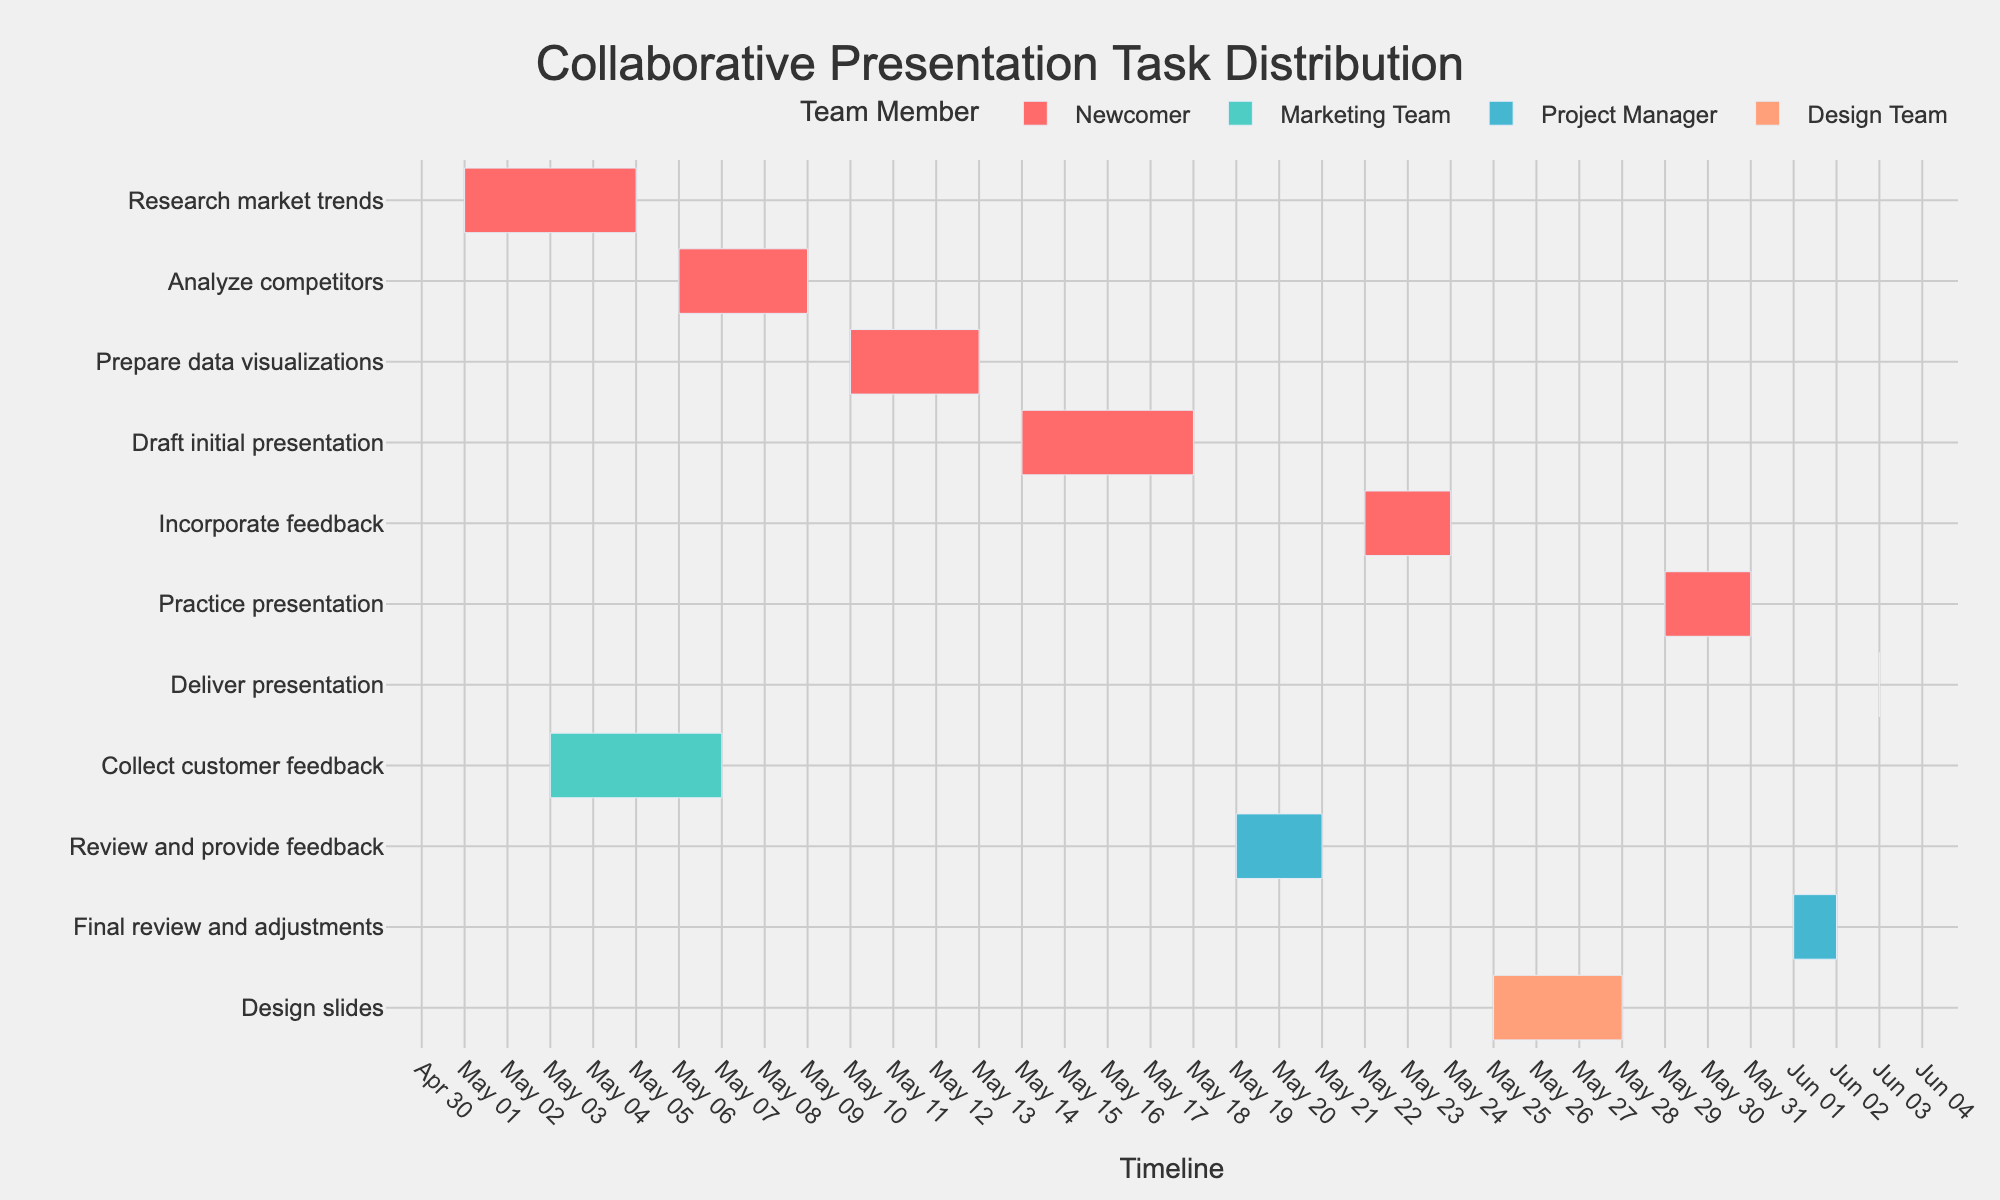What is the title of the Gantt chart? The title can be found at the top of the Gantt chart, it reads "Collaborative Presentation Task Distribution".
Answer: Collaborative Presentation Task Distribution Which team member has the most tasks assigned? By observing the color-coded legend and the tasks associated with each team member, we see that the Newcomer has the most tasks assigned.
Answer: Newcomer How long did the task "Analyze competitors" take? The start date for "Analyze competitors" is 2023-05-06 and the end date is 2023-05-09. Counting inclusively, this task took 4 days.
Answer: 4 days What tasks are assigned to the Design Team? The legend indicates colors for each team member. The Design Team is associated with a specific color, and we see "Design slides" is the task marked with this color.
Answer: Design slides Compare the duration of "Collect customer feedback" and "Prepare data visualizations". Which one took longer? "Collect customer feedback" runs from 2023-05-03 to 2023-05-07, which is 5 days long. "Prepare data visualizations" is from 2023-05-10 to 2023-05-13, which is 4 days long. Thus, "Collect customer feedback" took longer.
Answer: Collect customer feedback How many tasks did the Project Manager review or provide feedback on? By examining the tasks assigned to the Project Manager, we see they are involved in "Review and provide feedback" and "Final review and adjustments". There are 2 tasks.
Answer: 2 tasks What is the total duration of all tasks assigned to the Newcomer? Summing the individual durations: "Research market trends" (5 days), "Analyze competitors" (4 days), "Prepare data visualizations" (4 days), "Draft initial presentation" (5 days), "Incorporate feedback" (3 days), "Practice presentation" (3 days), and "Deliver presentation" (1 day), the total duration is 5 + 4 + 4 + 5 + 3 + 3 + 1 = 25 days.
Answer: 25 days How does the task "Draft initial presentation" align time-wise with "Review and provide feedback"? "Draft initial presentation" runs from 2023-05-14 to 2023-05-18. "Review and provide feedback" follows from 2023-05-19 to 2023-05-21, indicating that review and feedback start immediately after the initial presentation draft is completed.
Answer: Review starts after draft completion Among the tasks handled by the Newcomer, which one is the shortest in duration? By comparing the durations of tasks assigned to the Newcomer: "Research market trends" (5 days), "Analyze competitors" (4 days), "Prepare data visualizations" (4 days), "Draft initial presentation" (5 days), "Incorporate feedback" (3 days), "Practice presentation" (3 days), "Deliver presentation" (1 day), the "Deliver presentation" task is the shortest.
Answer: Deliver presentation What is the combined duration of tasks handled by the Marketing Team and the Design Team? The Marketing Team's task is "Collect customer feedback" (5 days). The Design Team's task is "Design slides" (4 days). The combined duration is 5 + 4 = 9 days.
Answer: 9 days 